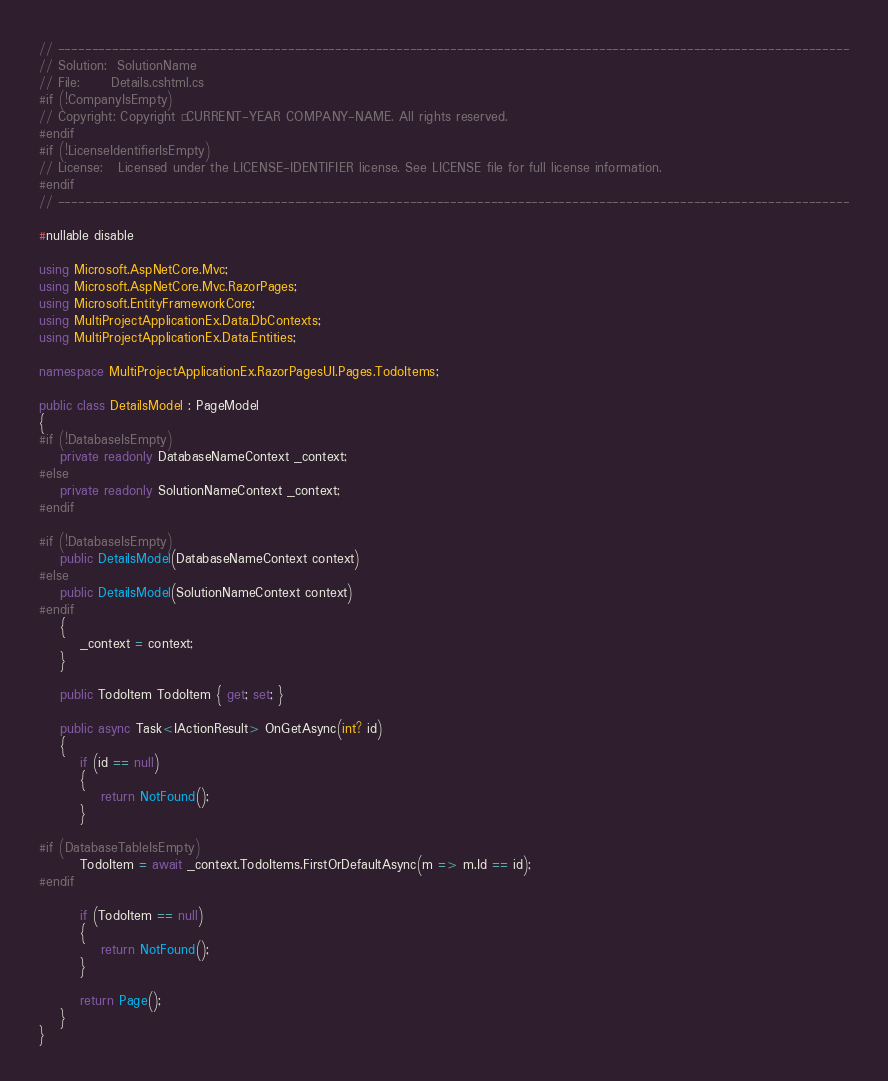Convert code to text. <code><loc_0><loc_0><loc_500><loc_500><_C#_>// ---------------------------------------------------------------------------------------------------------------------
// Solution:  SolutionName
// File:      Details.cshtml.cs
#if (!CompanyIsEmpty)
// Copyright: Copyright © CURRENT-YEAR COMPANY-NAME. All rights reserved.
#endif
#if (!LicenseIdentifierIsEmpty)
// License:   Licensed under the LICENSE-IDENTIFIER license. See LICENSE file for full license information.
#endif
// ---------------------------------------------------------------------------------------------------------------------

#nullable disable

using Microsoft.AspNetCore.Mvc;
using Microsoft.AspNetCore.Mvc.RazorPages;
using Microsoft.EntityFrameworkCore;
using MultiProjectApplicationEx.Data.DbContexts;
using MultiProjectApplicationEx.Data.Entities;

namespace MultiProjectApplicationEx.RazorPagesUI.Pages.TodoItems;

public class DetailsModel : PageModel
{
#if (!DatabaseIsEmpty)
    private readonly DatabaseNameContext _context;
#else
    private readonly SolutionNameContext _context;
#endif

#if (!DatabaseIsEmpty)
    public DetailsModel(DatabaseNameContext context)
#else
    public DetailsModel(SolutionNameContext context)
#endif
    {
        _context = context;
    }

    public TodoItem TodoItem { get; set; }

    public async Task<IActionResult> OnGetAsync(int? id)
    {
        if (id == null)
        {
            return NotFound();
        }

#if (DatabaseTableIsEmpty)
        TodoItem = await _context.TodoItems.FirstOrDefaultAsync(m => m.Id == id);
#endif

        if (TodoItem == null)
        {
            return NotFound();
        }

        return Page();
    }
}</code> 